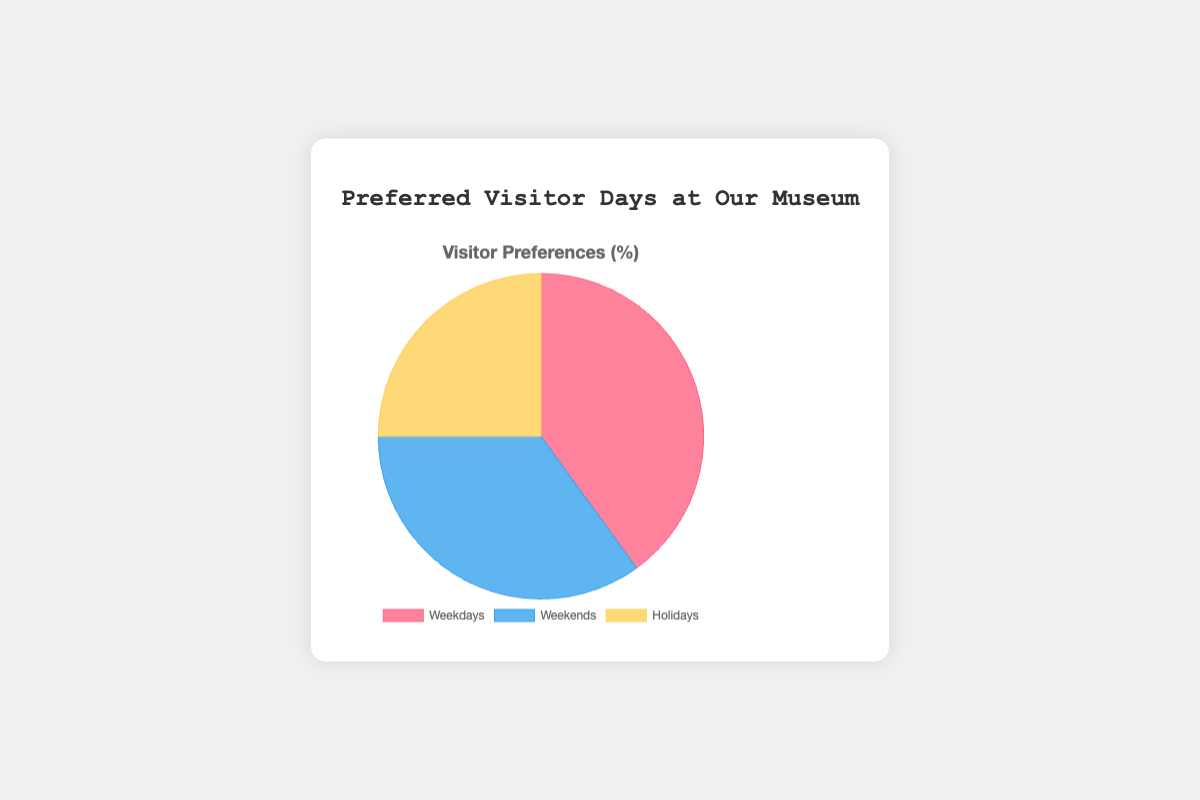Which day type has the highest visitor preference? By looking at the chart's segments, the "Weekdays" section is the largest.
Answer: Weekdays What percentage of visitors prefer weekends or holidays? Adding the percentages of Weekends (35%) and Holidays (25%) gives 35% + 25% = 60%.
Answer: 60% Which two day types together account for more than half of the visitor preferences? Adding percentages for Weekdays (40%) and Weekends (35%) gives 40% + 35% = 75%, which is more than 50%.
Answer: Weekdays and Weekends Is the preference for weekdays greater than weekends and holidays combined? Comparing Weekdays (40%) to the sum of Weekends (35%) and Holidays (25%) gives 40% vs 60%. Weekdays percentage is less.
Answer: No What is the difference in visitor preference between weekdays and holidays? Subtracting the percentage for Holidays (25%) from Weekdays (40%) gives 40% - 25% = 15%.
Answer: 15% Which day type has the lowest visitor preference and what color represents it? The smallest segment and its color indicate the day with the lowest preference, which is "Holidays" in yellow.
Answer: Holidays, Yellow How much more do visitors prefer weekends compared to holidays? Subtract the percentage for Holidays (25%) from Weekends (35%) gives 35% - 25% = 10%.
Answer: 10% If the preference for weekdays were to increase by 10%, what would the new percentage be? Adding 10% to the current weekdays percentage (40%) gives 40% + 10% = 50%.
Answer: 50% What is the average of the three visitor preferences? Sum of the percentages for Weekdays (40%), Weekends (35%), and Holidays (25%) gives 40% + 35% + 25% = 100%. The average is 100% / 3 = 33.33%.
Answer: 33.33% Given the current data, if each visitor could visit on any of the preferred days, what percent chance would a visitor have of choosing a holiday? The Holidays segment represents its share directly as 25%.
Answer: 25% 